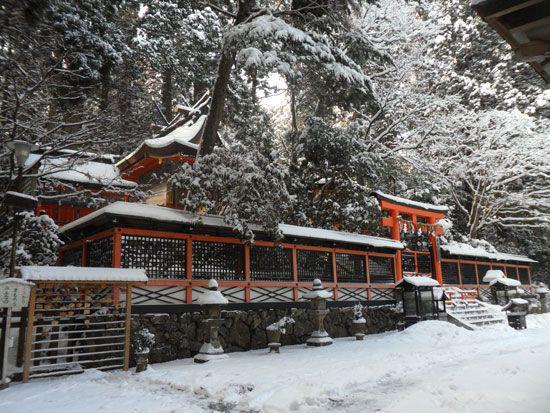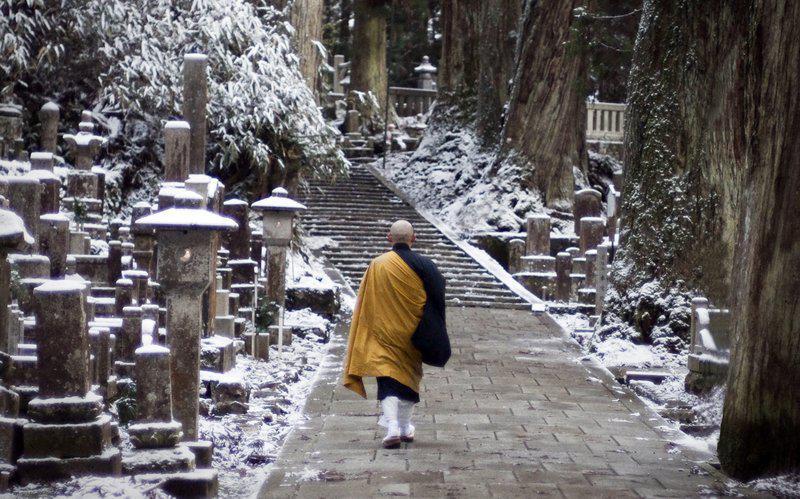The first image is the image on the left, the second image is the image on the right. Assess this claim about the two images: "An image shows at least three people in golden-yellow robes walking in a snowy scene.". Correct or not? Answer yes or no. No. The first image is the image on the left, the second image is the image on the right. Examine the images to the left and right. Is the description "The red posts of a Buddhist shrine can be seen in one image, while a single monk walks on a stone path in the other image." accurate? Answer yes or no. Yes. 